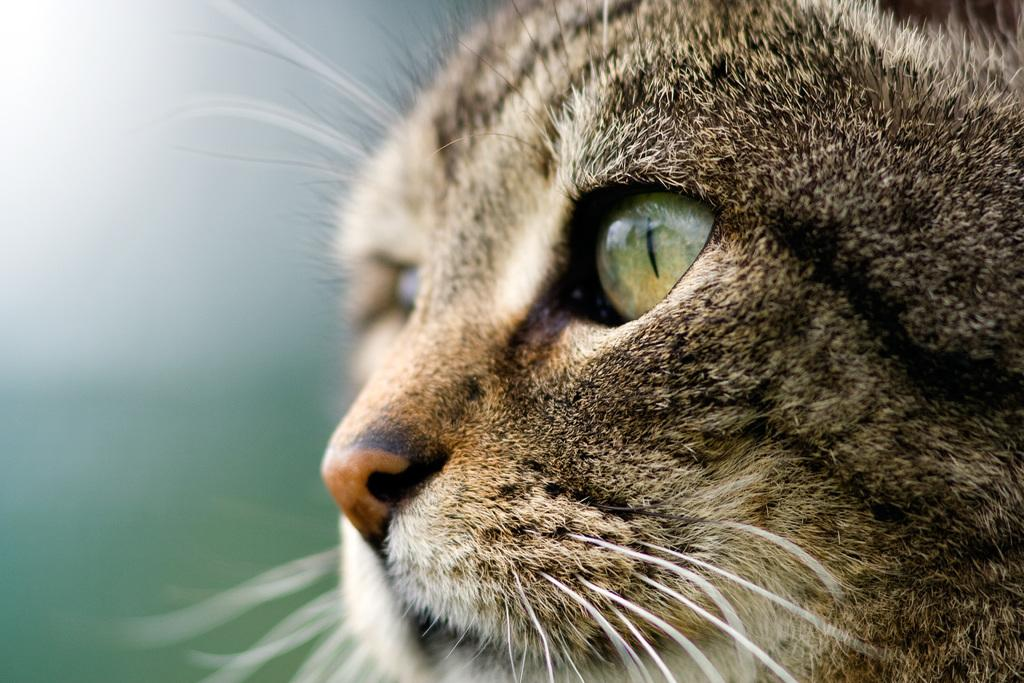What is the main subject of the image? The main subject of the image is a cat. Can you describe the background of the image? The background of the image is blurred. What type of plant can be seen growing in the background of the image? There is no plant visible in the background of the image, as it is blurred. 